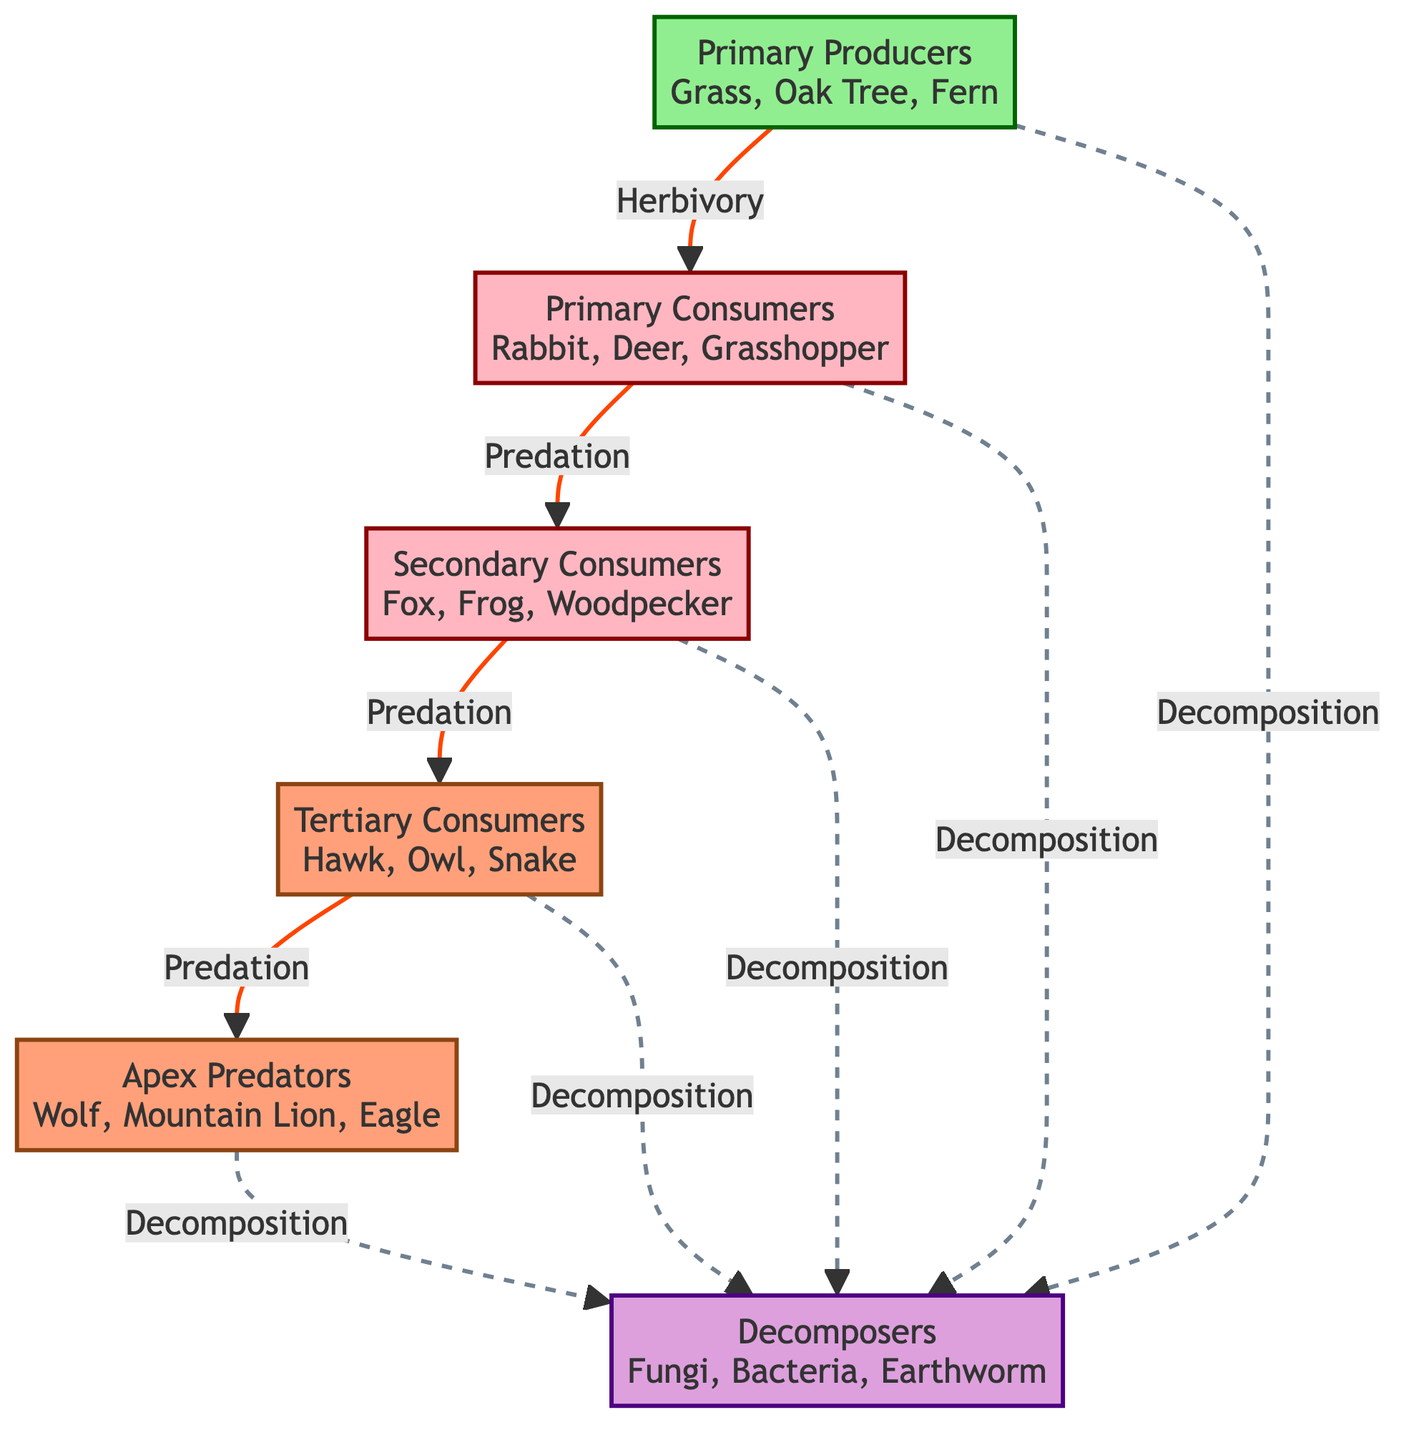What are the primary producers in this ecosystem? The diagram lists Grass, Oak Tree, and Fern as examples of primary producers, which are at the base of the energy flow in the ecosystem.
Answer: Grass, Oak Tree, Fern How many levels of consumers are present in the food chain? The diagram categorizes consumers into three levels: Primary Consumers, Secondary Consumers, and Tertiary Consumers. This sums up to three levels of consumers.
Answer: 3 What relationship exists between primary consumers and secondary consumers? The diagram indicates that the relationship is based on predation, where primary consumers (like Rabbit, Deer, Grasshopper) are preyed upon by secondary consumers (such as Fox, Frog, Woodpecker).
Answer: Predation Which organisms are classified as apex predators? According to the diagram, the apex predators are Wolf, Mountain Lion, and Eagle, which sit at the top of the food chain with no natural enemies.
Answer: Wolf, Mountain Lion, Eagle How do decomposers interact with apex predators in the ecosystem? The diagram shows that apex predators (like Wolf, Mountain Lion, Eagle) have a relationship with decomposers through decomposition. When apex predators die, they provide organic matter that decomposers (like Fungi, Bacteria, Earthworm) break down.
Answer: Decomposition What is the total number of nodes in the food chain diagram? Counting all the entities in the diagram, including primary producers, consumers, apex predators, and decomposers, there are a total of 8 nodes.
Answer: 8 What is the flow of energy from primary producers to apex predators? The energy flow starts from primary producers (Grass, Oak Tree, Fern), which are consumed by primary consumers (Rabbit, Deer, Grasshopper), then by secondary consumers (Fox, Frog, Woodpecker), followed by tertiary consumers (Hawk, Owl, Snake), and finally reaching apex predators (Wolf, Mountain Lion, Eagle).
Answer: Primary producers to apex predators How is the relationship between secondary consumers and tertiary consumers characterized? The relationship between secondary consumers (Fox, Frog, Woodpecker) and tertiary consumers (Hawk, Owl, Snake) is also based on predation, indicating that secondary consumers serve as prey for tertiary consumers.
Answer: Predation 